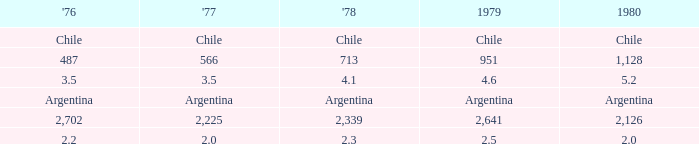What is 1980 when 1979 is 951? 1128.0. Can you give me this table as a dict? {'header': ["'76", "'77", "'78", '1979', '1980'], 'rows': [['Chile', 'Chile', 'Chile', 'Chile', 'Chile'], ['487', '566', '713', '951', '1,128'], ['3.5', '3.5', '4.1', '4.6', '5.2'], ['Argentina', 'Argentina', 'Argentina', 'Argentina', 'Argentina'], ['2,702', '2,225', '2,339', '2,641', '2,126'], ['2.2', '2.0', '2.3', '2.5', '2.0']]} 